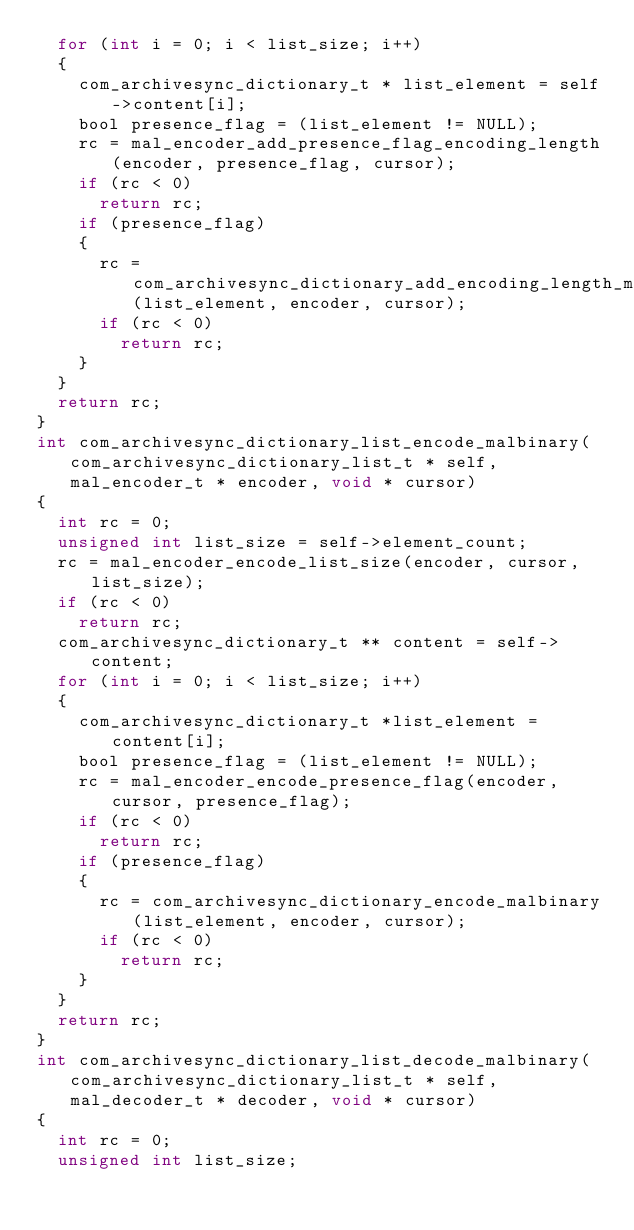Convert code to text. <code><loc_0><loc_0><loc_500><loc_500><_C_>  for (int i = 0; i < list_size; i++)
  {
    com_archivesync_dictionary_t * list_element = self->content[i];
    bool presence_flag = (list_element != NULL);
    rc = mal_encoder_add_presence_flag_encoding_length(encoder, presence_flag, cursor);
    if (rc < 0)
      return rc;
    if (presence_flag)
    {
      rc = com_archivesync_dictionary_add_encoding_length_malbinary(list_element, encoder, cursor);
      if (rc < 0)
        return rc;
    }
  }
  return rc;
}
int com_archivesync_dictionary_list_encode_malbinary(com_archivesync_dictionary_list_t * self, mal_encoder_t * encoder, void * cursor)
{
  int rc = 0;
  unsigned int list_size = self->element_count;
  rc = mal_encoder_encode_list_size(encoder, cursor, list_size);
  if (rc < 0)
    return rc;
  com_archivesync_dictionary_t ** content = self->content;
  for (int i = 0; i < list_size; i++)
  {
    com_archivesync_dictionary_t *list_element = content[i];
    bool presence_flag = (list_element != NULL);
    rc = mal_encoder_encode_presence_flag(encoder, cursor, presence_flag);
    if (rc < 0)
      return rc;
    if (presence_flag)
    {
      rc = com_archivesync_dictionary_encode_malbinary(list_element, encoder, cursor);
      if (rc < 0)
        return rc;
    }
  }
  return rc;
}
int com_archivesync_dictionary_list_decode_malbinary(com_archivesync_dictionary_list_t * self, mal_decoder_t * decoder, void * cursor)
{
  int rc = 0;
  unsigned int list_size;</code> 